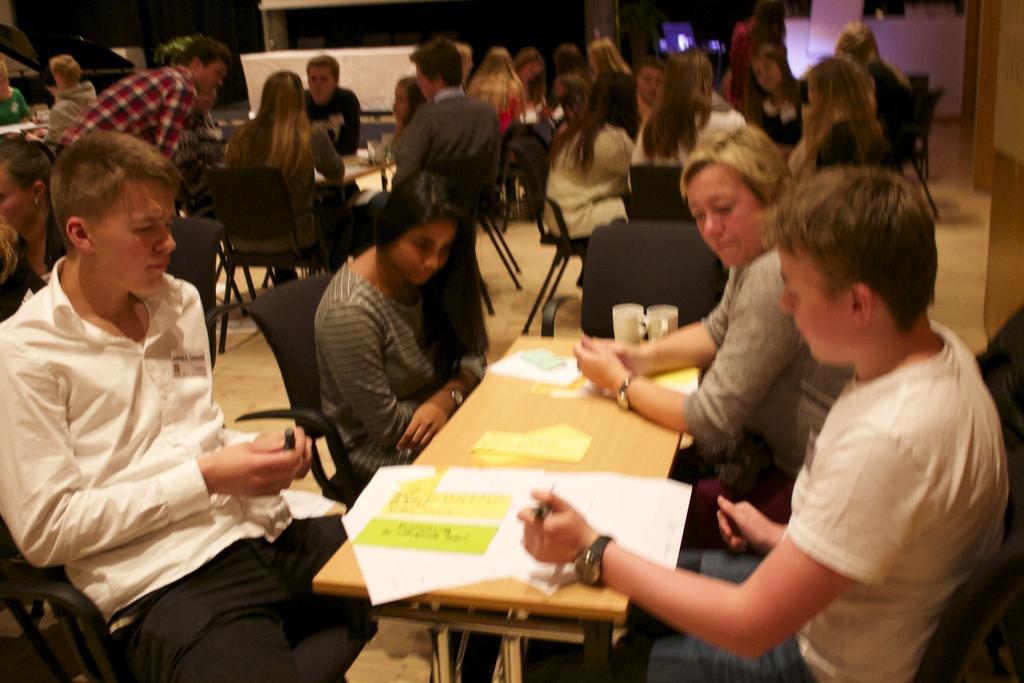Can you describe this image briefly? In this image i can see group of people sitting on chair there is a paper, two glasses on a table at the back ground i can see a wooden wall. 